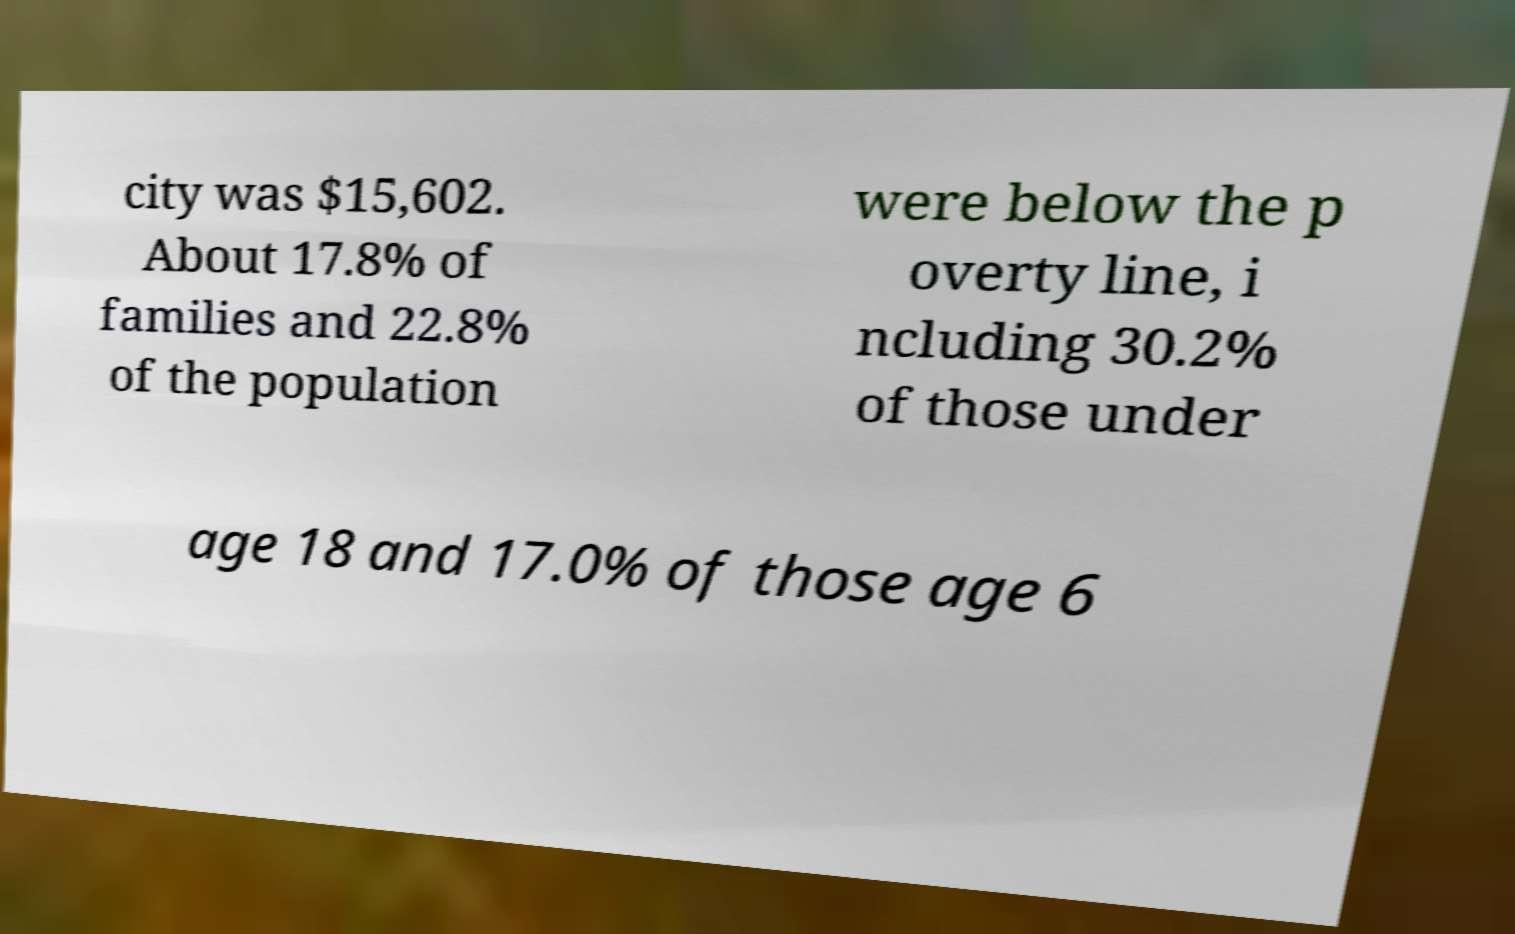Please identify and transcribe the text found in this image. city was $15,602. About 17.8% of families and 22.8% of the population were below the p overty line, i ncluding 30.2% of those under age 18 and 17.0% of those age 6 